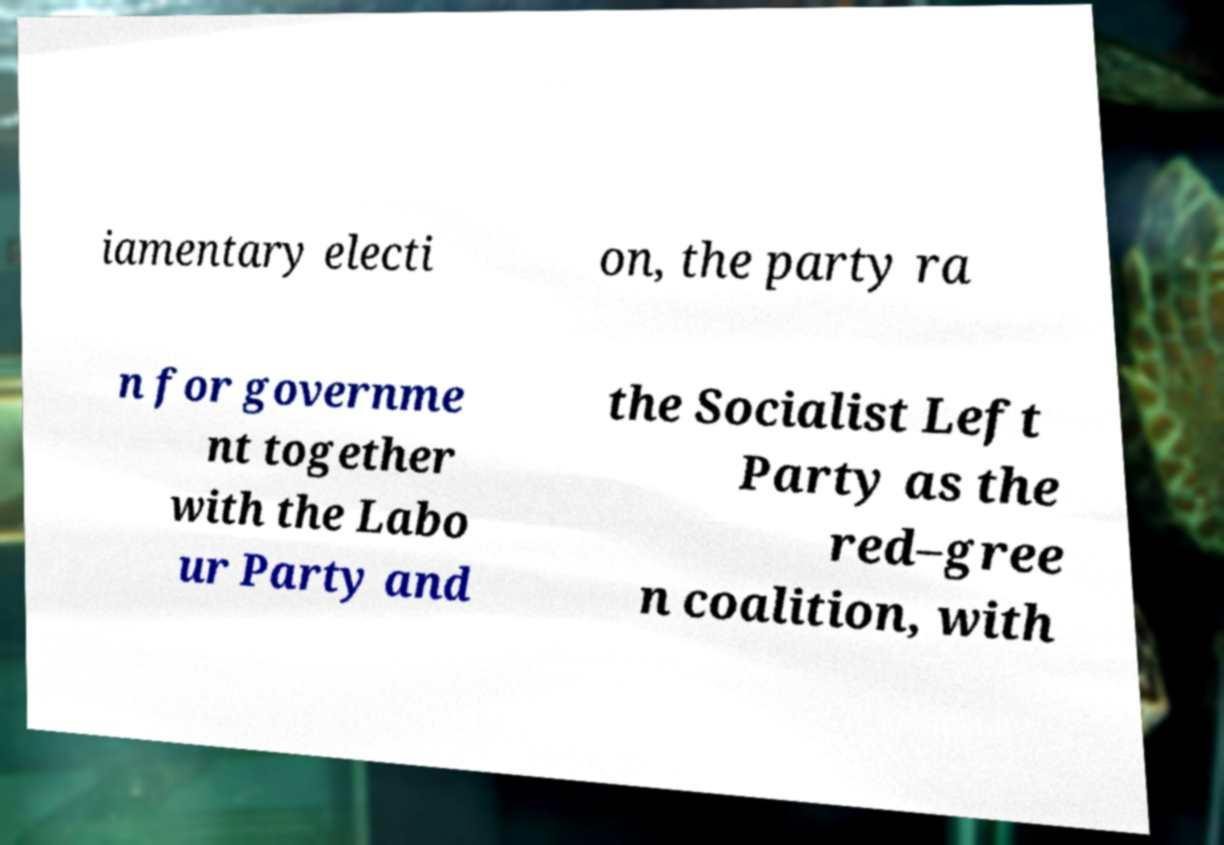Please identify and transcribe the text found in this image. iamentary electi on, the party ra n for governme nt together with the Labo ur Party and the Socialist Left Party as the red–gree n coalition, with 